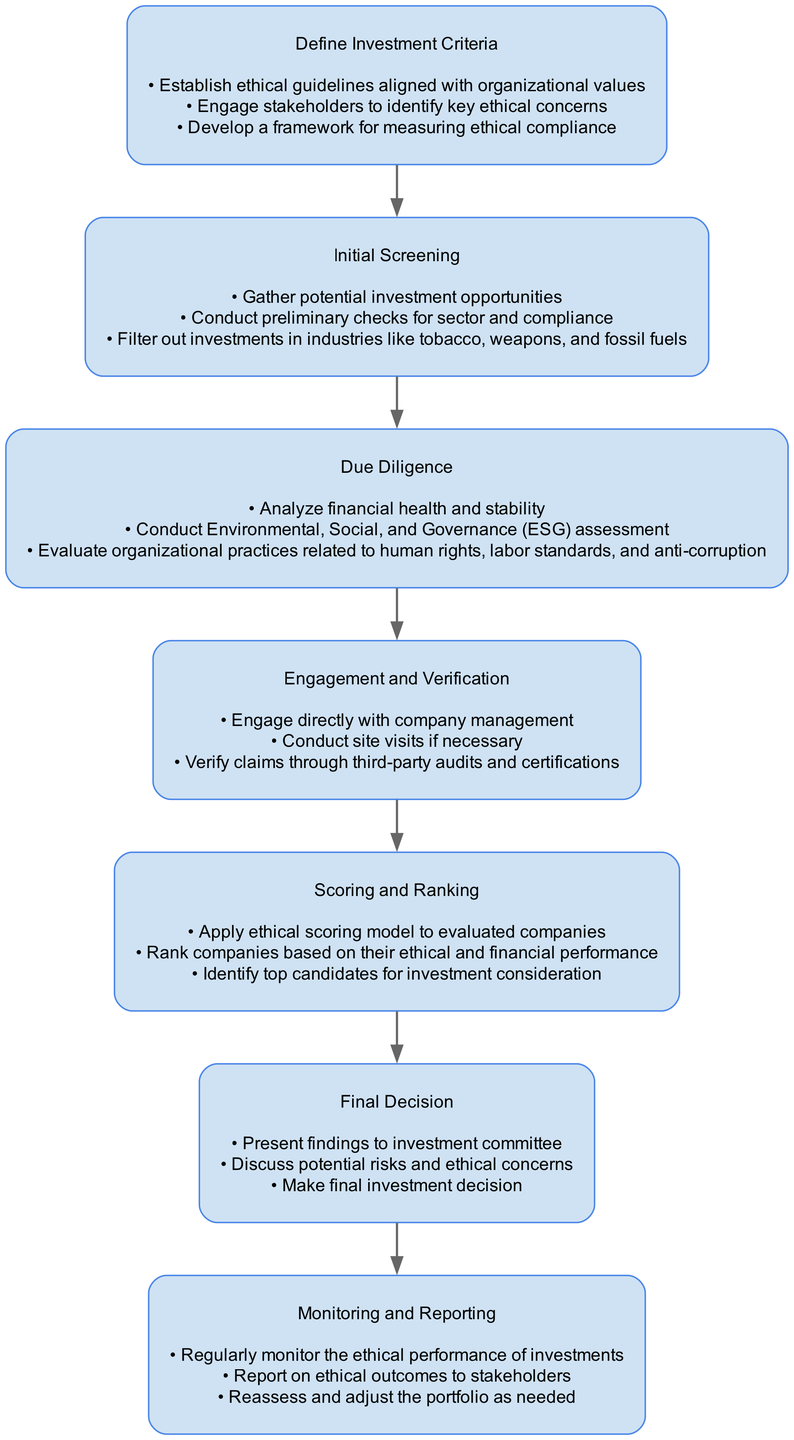What is the title of the diagram? The title is provided at the top of the diagram, indicating the main focus of the flowchart. It reads "Screening Potential Ethical Investments: A Step-by-Step Process"
Answer: Screening Potential Ethical Investments: A Step-by-Step Process How many stages are present in the process? By counting the distinct stages listed in the diagram, there are seven clear stages that outline the process from defining investment criteria to monitoring and reporting.
Answer: 7 What is the first stage of the process? The first stage is highlighted at the beginning of the flow, which clearly presents the initial step in the process of screening investments. It is labeled "Define Investment Criteria."
Answer: Define Investment Criteria What task is performed in the "Due Diligence" stage? Reviewing the tasks listed under "Due Diligence", one such task involves conducting an Environmental, Social, and Governance (ESG) assessment, which is crucial for evaluating ethical compliance.
Answer: Conduct Environmental, Social, and Governance (ESG) assessment What stage follows "Engagement and Verification"? By examining the flow from one stage to the next, it is evident that the stage that occurs after "Engagement and Verification" is "Scoring and Ranking."
Answer: Scoring and Ranking Which stage involves presenting findings to an investment committee? Within the stages, the final decision-making activities are encapsulated in the "Final Decision" stage, where findings are discussed and presented.
Answer: Final Decision What is the focus of the "Monitoring and Reporting" stage? The "Monitoring and Reporting" stage includes several tasks centered around the ongoing assessment and communication of ethical performance, ensuring continuous evaluation after investment.
Answer: Regularly monitor the ethical performance of investments How is the process structured in terms of flow? The process is structured as a linear flow chart, beginning with defining criteria and moving sequentially through each stage to the final decision and ongoing monitoring, indicating a systematic approach.
Answer: Linear flow chart What criteria are used to filter out investments during the "Initial Screening"? In the "Initial Screening" stage, investments in specific industries such as tobacco, weapons, and fossil fuels are filtered out based on ethical guidelines.
Answer: Tobacco, weapons, and fossil fuels 